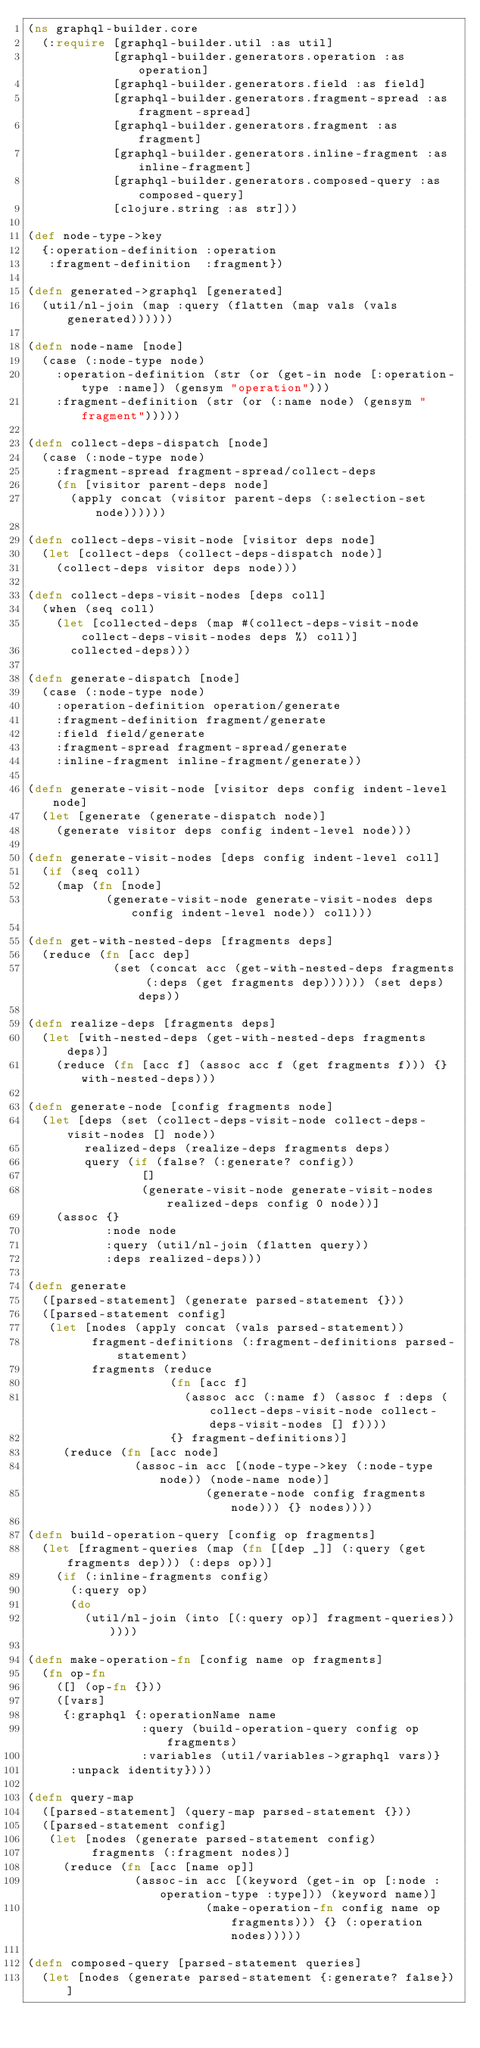<code> <loc_0><loc_0><loc_500><loc_500><_Clojure_>(ns graphql-builder.core
  (:require [graphql-builder.util :as util]
            [graphql-builder.generators.operation :as operation]
            [graphql-builder.generators.field :as field]
            [graphql-builder.generators.fragment-spread :as fragment-spread]
            [graphql-builder.generators.fragment :as fragment]
            [graphql-builder.generators.inline-fragment :as inline-fragment]
            [graphql-builder.generators.composed-query :as composed-query]
            [clojure.string :as str]))

(def node-type->key
  {:operation-definition :operation
   :fragment-definition  :fragment})

(defn generated->graphql [generated]
  (util/nl-join (map :query (flatten (map vals (vals generated))))))

(defn node-name [node]
  (case (:node-type node)
    :operation-definition (str (or (get-in node [:operation-type :name]) (gensym "operation")))
    :fragment-definition (str (or (:name node) (gensym "fragment")))))

(defn collect-deps-dispatch [node]
  (case (:node-type node)
    :fragment-spread fragment-spread/collect-deps
    (fn [visitor parent-deps node]
      (apply concat (visitor parent-deps (:selection-set node))))))

(defn collect-deps-visit-node [visitor deps node]
  (let [collect-deps (collect-deps-dispatch node)]
    (collect-deps visitor deps node)))

(defn collect-deps-visit-nodes [deps coll]
  (when (seq coll)
    (let [collected-deps (map #(collect-deps-visit-node collect-deps-visit-nodes deps %) coll)]
      collected-deps)))

(defn generate-dispatch [node]
  (case (:node-type node)
    :operation-definition operation/generate
    :fragment-definition fragment/generate
    :field field/generate
    :fragment-spread fragment-spread/generate
    :inline-fragment inline-fragment/generate))

(defn generate-visit-node [visitor deps config indent-level node]
  (let [generate (generate-dispatch node)]
    (generate visitor deps config indent-level node)))

(defn generate-visit-nodes [deps config indent-level coll]
  (if (seq coll)
    (map (fn [node]
           (generate-visit-node generate-visit-nodes deps config indent-level node)) coll)))

(defn get-with-nested-deps [fragments deps]
  (reduce (fn [acc dep]
            (set (concat acc (get-with-nested-deps fragments (:deps (get fragments dep)))))) (set deps) deps))

(defn realize-deps [fragments deps]
  (let [with-nested-deps (get-with-nested-deps fragments deps)]
    (reduce (fn [acc f] (assoc acc f (get fragments f))) {} with-nested-deps)))

(defn generate-node [config fragments node]
  (let [deps (set (collect-deps-visit-node collect-deps-visit-nodes [] node))
        realized-deps (realize-deps fragments deps)
        query (if (false? (:generate? config))
                []
                (generate-visit-node generate-visit-nodes realized-deps config 0 node))]
    (assoc {}
           :node node
           :query (util/nl-join (flatten query))
           :deps realized-deps)))

(defn generate
  ([parsed-statement] (generate parsed-statement {}))
  ([parsed-statement config]
   (let [nodes (apply concat (vals parsed-statement))
         fragment-definitions (:fragment-definitions parsed-statement)
         fragments (reduce
                    (fn [acc f]
                      (assoc acc (:name f) (assoc f :deps (collect-deps-visit-node collect-deps-visit-nodes [] f))))
                    {} fragment-definitions)]
     (reduce (fn [acc node]
               (assoc-in acc [(node-type->key (:node-type node)) (node-name node)]
                         (generate-node config fragments node))) {} nodes))))

(defn build-operation-query [config op fragments]
  (let [fragment-queries (map (fn [[dep _]] (:query (get fragments dep))) (:deps op))]
    (if (:inline-fragments config)
      (:query op)
      (do
        (util/nl-join (into [(:query op)] fragment-queries))))))

(defn make-operation-fn [config name op fragments]
  (fn op-fn
    ([] (op-fn {}))
    ([vars]
     {:graphql {:operationName name
                :query (build-operation-query config op fragments)
                :variables (util/variables->graphql vars)}
      :unpack identity})))

(defn query-map
  ([parsed-statement] (query-map parsed-statement {}))
  ([parsed-statement config]
   (let [nodes (generate parsed-statement config)
         fragments (:fragment nodes)]
     (reduce (fn [acc [name op]]
               (assoc-in acc [(keyword (get-in op [:node :operation-type :type])) (keyword name)]
                         (make-operation-fn config name op fragments))) {} (:operation nodes)))))

(defn composed-query [parsed-statement queries]
  (let [nodes (generate parsed-statement {:generate? false})]</code> 